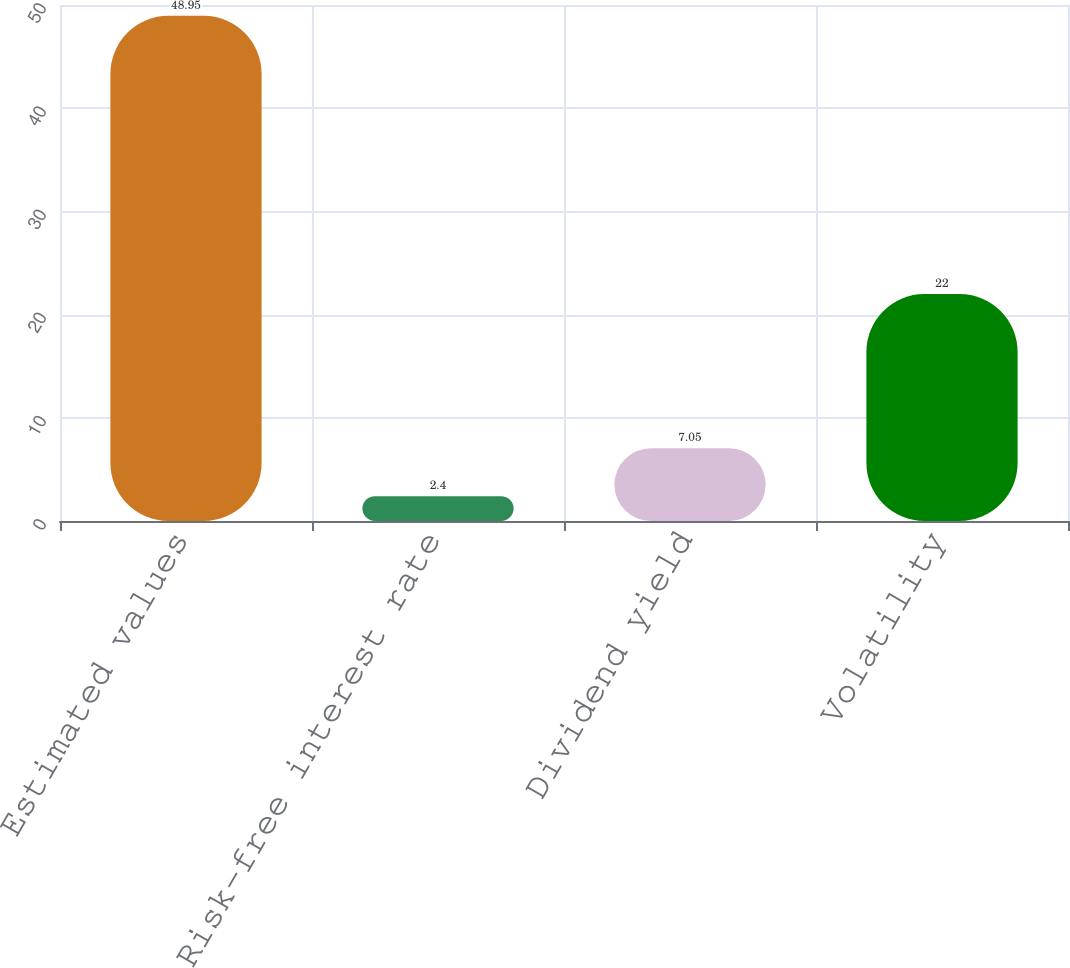Convert chart to OTSL. <chart><loc_0><loc_0><loc_500><loc_500><bar_chart><fcel>Estimated values<fcel>Risk-free interest rate<fcel>Dividend yield<fcel>Volatility<nl><fcel>48.95<fcel>2.4<fcel>7.05<fcel>22<nl></chart> 